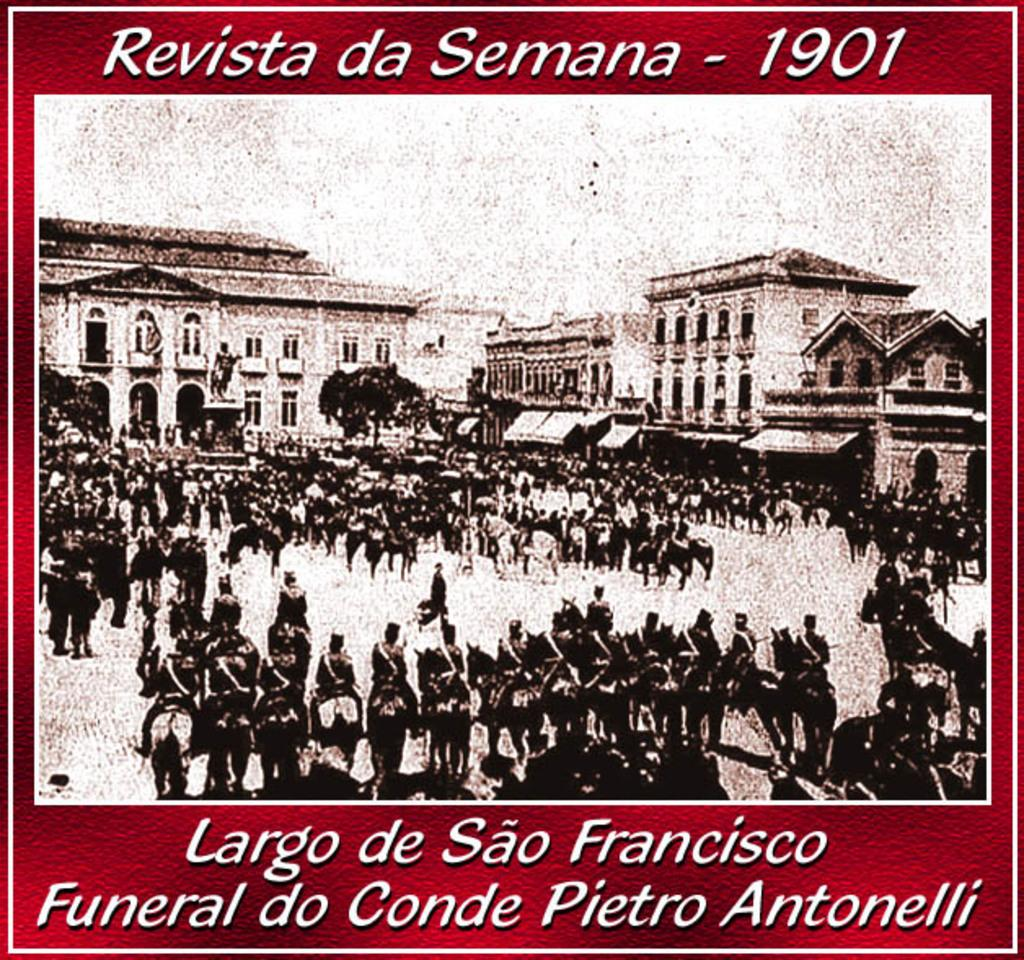<image>
Provide a brief description of the given image. an outdoor photo with the year 1901 at the top 